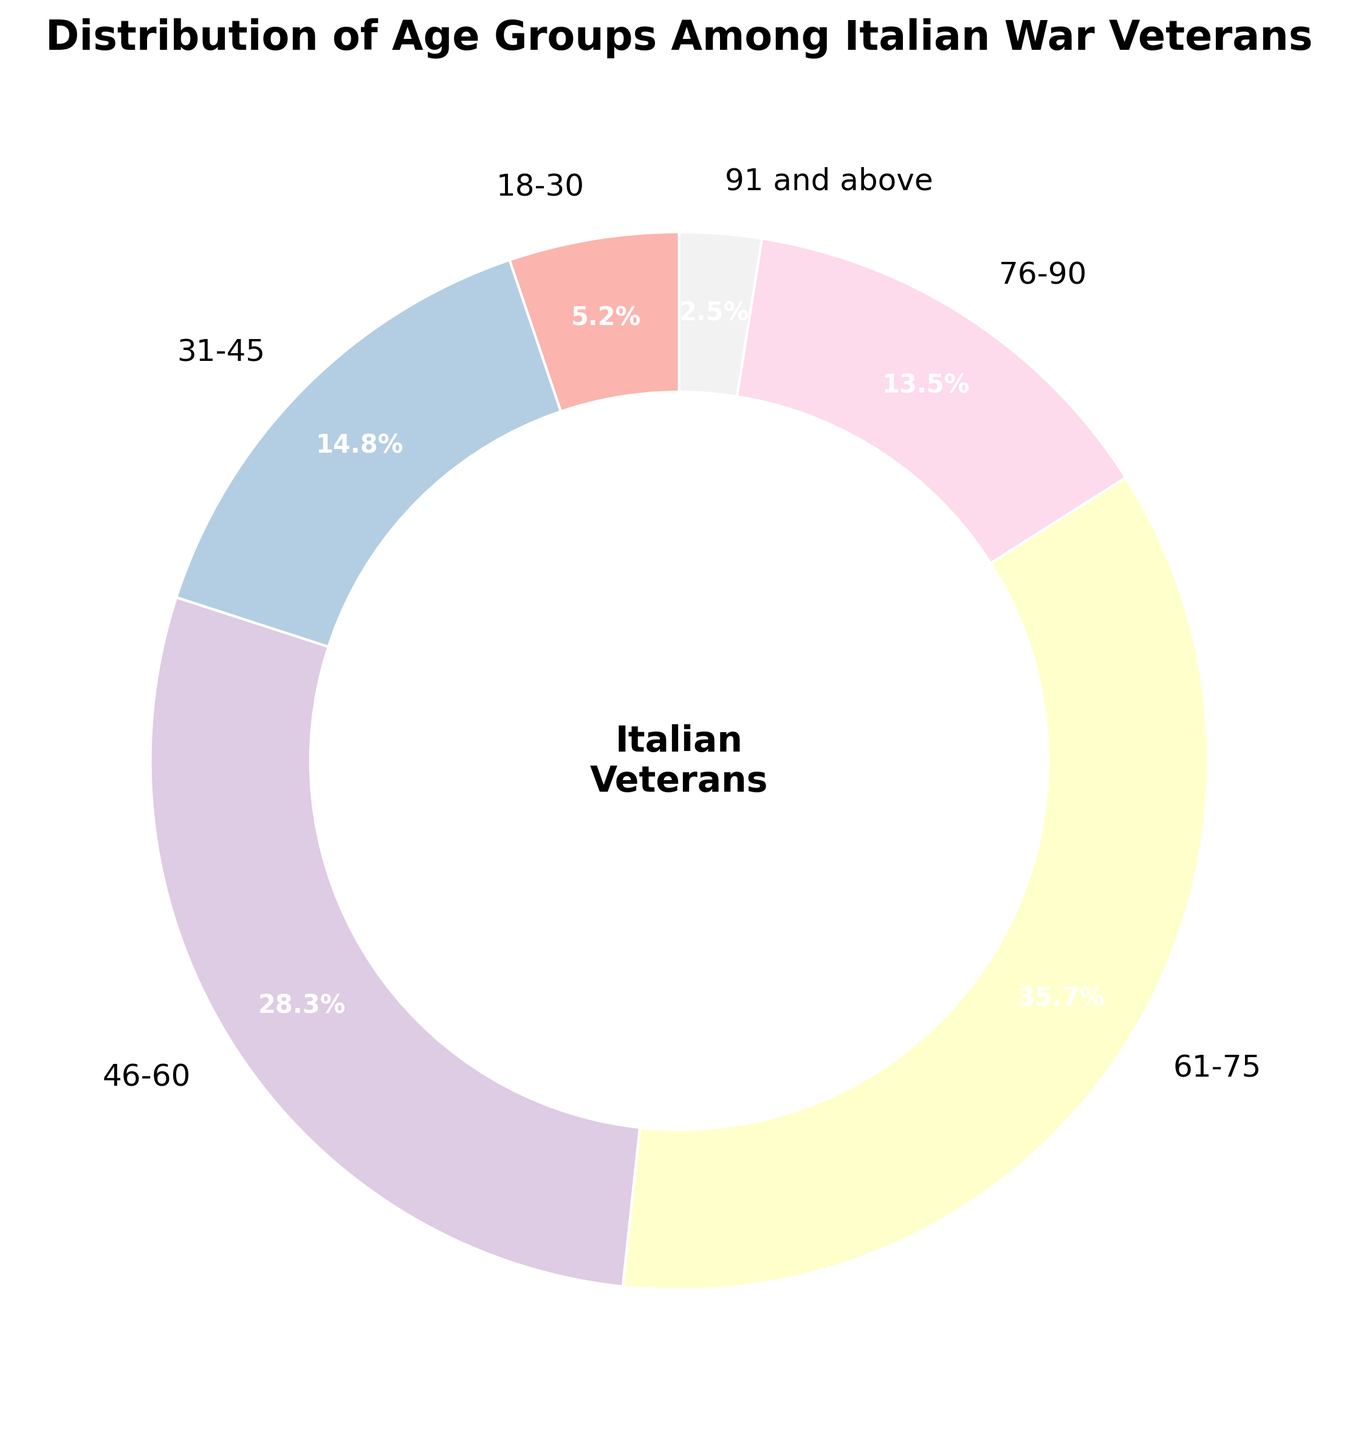Which age group has the highest percentage? By looking at the pie chart, we can see the segment that is the largest. It corresponds to the age group labeled 61-75.
Answer: 61-75 What is the total percentage of veterans aged 46-75? Add the percentages of the 46-60 and 61-75 age groups. These are 28.3% and 35.7%, respectively. Thus, 28.3% + 35.7% = 64%.
Answer: 64% Which age group has the smallest representation? By examining the smallest segment in the pie chart, it corresponds to the 91 and above age group.
Answer: 91 and above How does the percentage of veterans aged 31-45 compare to those aged 76-90? By comparing the sizes of the pie chart segments or checking the percentages, the age group 31-45 is 14.8% and the 76-90 group is 13.5%. Since 14.8% is greater than 13.5%, the 31-45 group has a higher percentage.
Answer: 31-45 has a higher percentage What proportion of veterans are aged 18-30 compared to those aged 91 and above? Compare the percentages of the 18-30 age group at 5.2% and 91 and above at 2.5%. Divide 5.2 by 2.5 to see that the 18-30 group is 2.08 times the 91 and above group.
Answer: 2.08 times How much larger is the 46-60 age group than the 18-30 age group? Subtract the percentage of the 18-30 group from the 46-60 group. This is 28.3% - 5.2% = 23.1%.
Answer: 23.1% What is the average percentage of all age groups? Sum up all the percentages and divide by the number of age groups. (5.2 + 14.8 + 28.3 + 35.7 + 13.5 + 2.5) / 6 = 100 / 6 ≈ 16.67%.
Answer: 16.67% What color represents the 61-75 age group in the pie chart? The segment of the pie chart corresponding to the 61-75 age group appears in the shade of yellow from the Pastel1 color palette.
Answer: Yellow Which two age groups combined have the closest percentage to half of the total population? Sum the percentages of various combinations to find the closest to 50%. The 46-60 (28.3%) and 18-30 (5.2%) combined are 33.5%, and the 76-90 (13.5%) and 31-45 (14.8%) combined are 28.3%. The 61-75 (35.7%) and 91 and above (2.5%) combined are 38.2%. The closest combination (45.7%) is the 46-60 and 31-45 groups together: 28.3 + 14.8 = 43.1%.
Answer: 46-60 and 31-45 Which age groups cumulatively cover over 50% of the veteran population? Start summing from the largest percentage age groups until exceeding 50%. The 61-75 group is 35.7%, and adding the 46-60 group (28.3%) gives a total of 64%, which is over 50%. Hence, age groups 46-60 and 61-75 together cover over 50%.
Answer: 46-60 and 61-75 